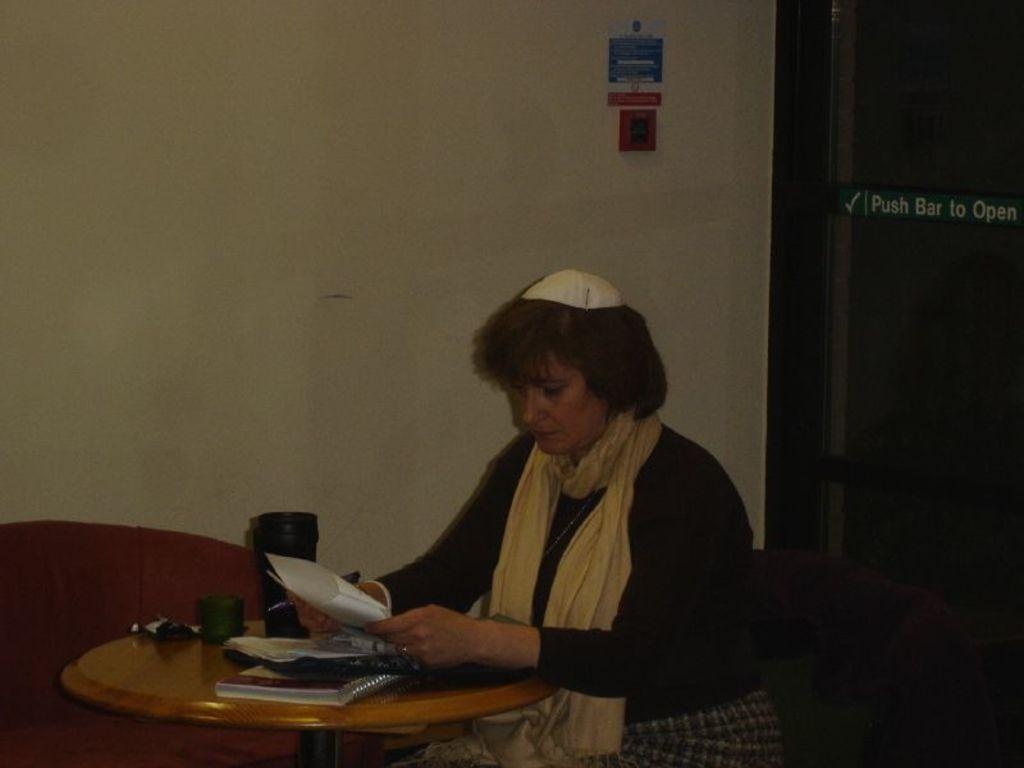Who is present in the image? There is a woman in the image. What is the woman holding in her hand? The woman is holding a paper and a pen. What is the primary object on the table in the image? There is a book on the table. Are there any other items on the table besides the book? Yes, there are additional items on the table. What type of hair is the woman wearing in the image? The image does not show the woman's hair, so it cannot be determined from the image. 